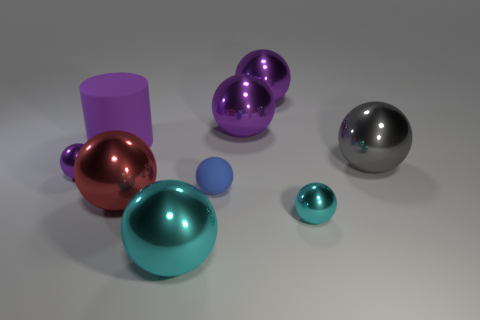Add 1 large red metal balls. How many objects exist? 10 Subtract all blue spheres. How many spheres are left? 7 Subtract 0 brown cylinders. How many objects are left? 9 Subtract all cylinders. How many objects are left? 8 Subtract 1 cylinders. How many cylinders are left? 0 Subtract all cyan balls. Subtract all brown blocks. How many balls are left? 6 Subtract all red cubes. How many purple balls are left? 3 Subtract all large matte cylinders. Subtract all large purple rubber things. How many objects are left? 7 Add 4 large gray balls. How many large gray balls are left? 5 Add 9 small purple metal objects. How many small purple metal objects exist? 10 